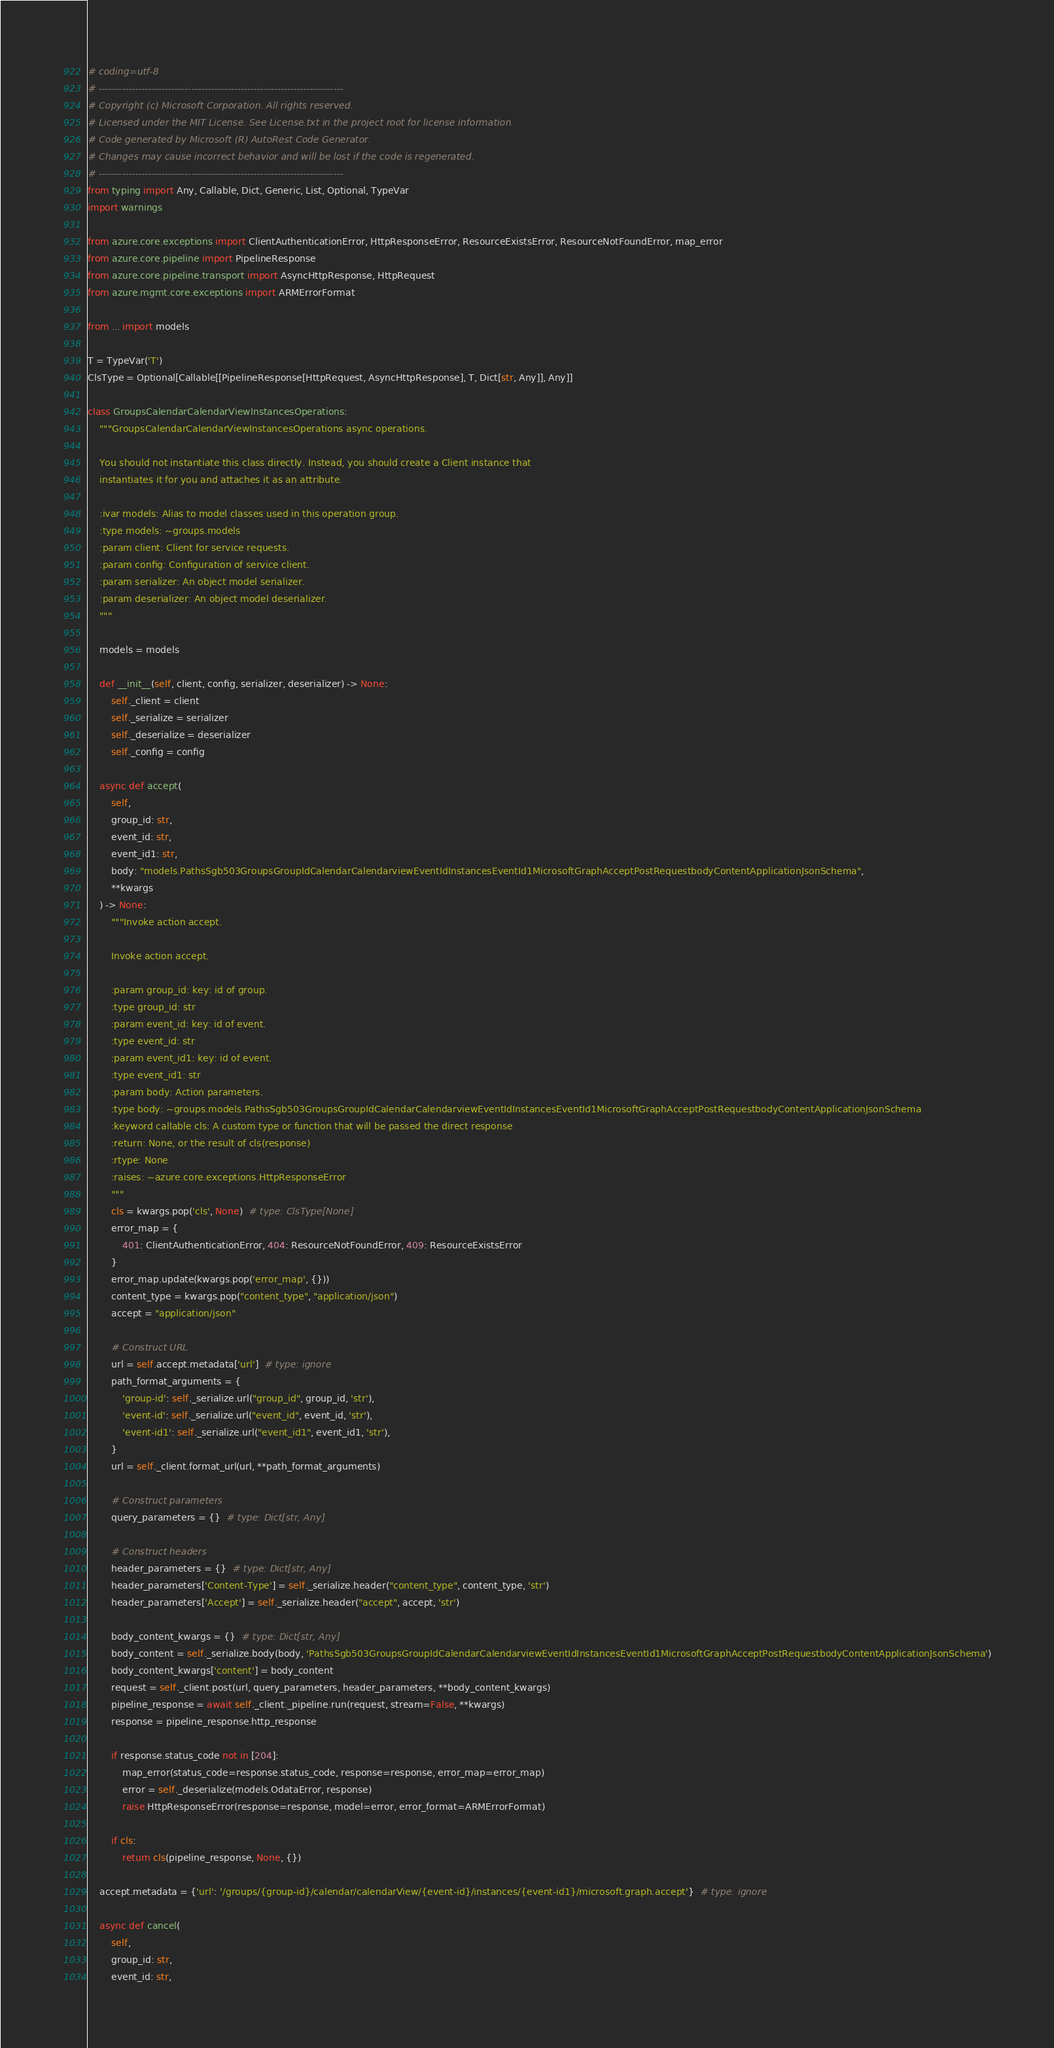Convert code to text. <code><loc_0><loc_0><loc_500><loc_500><_Python_># coding=utf-8
# --------------------------------------------------------------------------
# Copyright (c) Microsoft Corporation. All rights reserved.
# Licensed under the MIT License. See License.txt in the project root for license information.
# Code generated by Microsoft (R) AutoRest Code Generator.
# Changes may cause incorrect behavior and will be lost if the code is regenerated.
# --------------------------------------------------------------------------
from typing import Any, Callable, Dict, Generic, List, Optional, TypeVar
import warnings

from azure.core.exceptions import ClientAuthenticationError, HttpResponseError, ResourceExistsError, ResourceNotFoundError, map_error
from azure.core.pipeline import PipelineResponse
from azure.core.pipeline.transport import AsyncHttpResponse, HttpRequest
from azure.mgmt.core.exceptions import ARMErrorFormat

from ... import models

T = TypeVar('T')
ClsType = Optional[Callable[[PipelineResponse[HttpRequest, AsyncHttpResponse], T, Dict[str, Any]], Any]]

class GroupsCalendarCalendarViewInstancesOperations:
    """GroupsCalendarCalendarViewInstancesOperations async operations.

    You should not instantiate this class directly. Instead, you should create a Client instance that
    instantiates it for you and attaches it as an attribute.

    :ivar models: Alias to model classes used in this operation group.
    :type models: ~groups.models
    :param client: Client for service requests.
    :param config: Configuration of service client.
    :param serializer: An object model serializer.
    :param deserializer: An object model deserializer.
    """

    models = models

    def __init__(self, client, config, serializer, deserializer) -> None:
        self._client = client
        self._serialize = serializer
        self._deserialize = deserializer
        self._config = config

    async def accept(
        self,
        group_id: str,
        event_id: str,
        event_id1: str,
        body: "models.PathsSgb503GroupsGroupIdCalendarCalendarviewEventIdInstancesEventId1MicrosoftGraphAcceptPostRequestbodyContentApplicationJsonSchema",
        **kwargs
    ) -> None:
        """Invoke action accept.

        Invoke action accept.

        :param group_id: key: id of group.
        :type group_id: str
        :param event_id: key: id of event.
        :type event_id: str
        :param event_id1: key: id of event.
        :type event_id1: str
        :param body: Action parameters.
        :type body: ~groups.models.PathsSgb503GroupsGroupIdCalendarCalendarviewEventIdInstancesEventId1MicrosoftGraphAcceptPostRequestbodyContentApplicationJsonSchema
        :keyword callable cls: A custom type or function that will be passed the direct response
        :return: None, or the result of cls(response)
        :rtype: None
        :raises: ~azure.core.exceptions.HttpResponseError
        """
        cls = kwargs.pop('cls', None)  # type: ClsType[None]
        error_map = {
            401: ClientAuthenticationError, 404: ResourceNotFoundError, 409: ResourceExistsError
        }
        error_map.update(kwargs.pop('error_map', {}))
        content_type = kwargs.pop("content_type", "application/json")
        accept = "application/json"

        # Construct URL
        url = self.accept.metadata['url']  # type: ignore
        path_format_arguments = {
            'group-id': self._serialize.url("group_id", group_id, 'str'),
            'event-id': self._serialize.url("event_id", event_id, 'str'),
            'event-id1': self._serialize.url("event_id1", event_id1, 'str'),
        }
        url = self._client.format_url(url, **path_format_arguments)

        # Construct parameters
        query_parameters = {}  # type: Dict[str, Any]

        # Construct headers
        header_parameters = {}  # type: Dict[str, Any]
        header_parameters['Content-Type'] = self._serialize.header("content_type", content_type, 'str')
        header_parameters['Accept'] = self._serialize.header("accept", accept, 'str')

        body_content_kwargs = {}  # type: Dict[str, Any]
        body_content = self._serialize.body(body, 'PathsSgb503GroupsGroupIdCalendarCalendarviewEventIdInstancesEventId1MicrosoftGraphAcceptPostRequestbodyContentApplicationJsonSchema')
        body_content_kwargs['content'] = body_content
        request = self._client.post(url, query_parameters, header_parameters, **body_content_kwargs)
        pipeline_response = await self._client._pipeline.run(request, stream=False, **kwargs)
        response = pipeline_response.http_response

        if response.status_code not in [204]:
            map_error(status_code=response.status_code, response=response, error_map=error_map)
            error = self._deserialize(models.OdataError, response)
            raise HttpResponseError(response=response, model=error, error_format=ARMErrorFormat)

        if cls:
            return cls(pipeline_response, None, {})

    accept.metadata = {'url': '/groups/{group-id}/calendar/calendarView/{event-id}/instances/{event-id1}/microsoft.graph.accept'}  # type: ignore

    async def cancel(
        self,
        group_id: str,
        event_id: str,</code> 